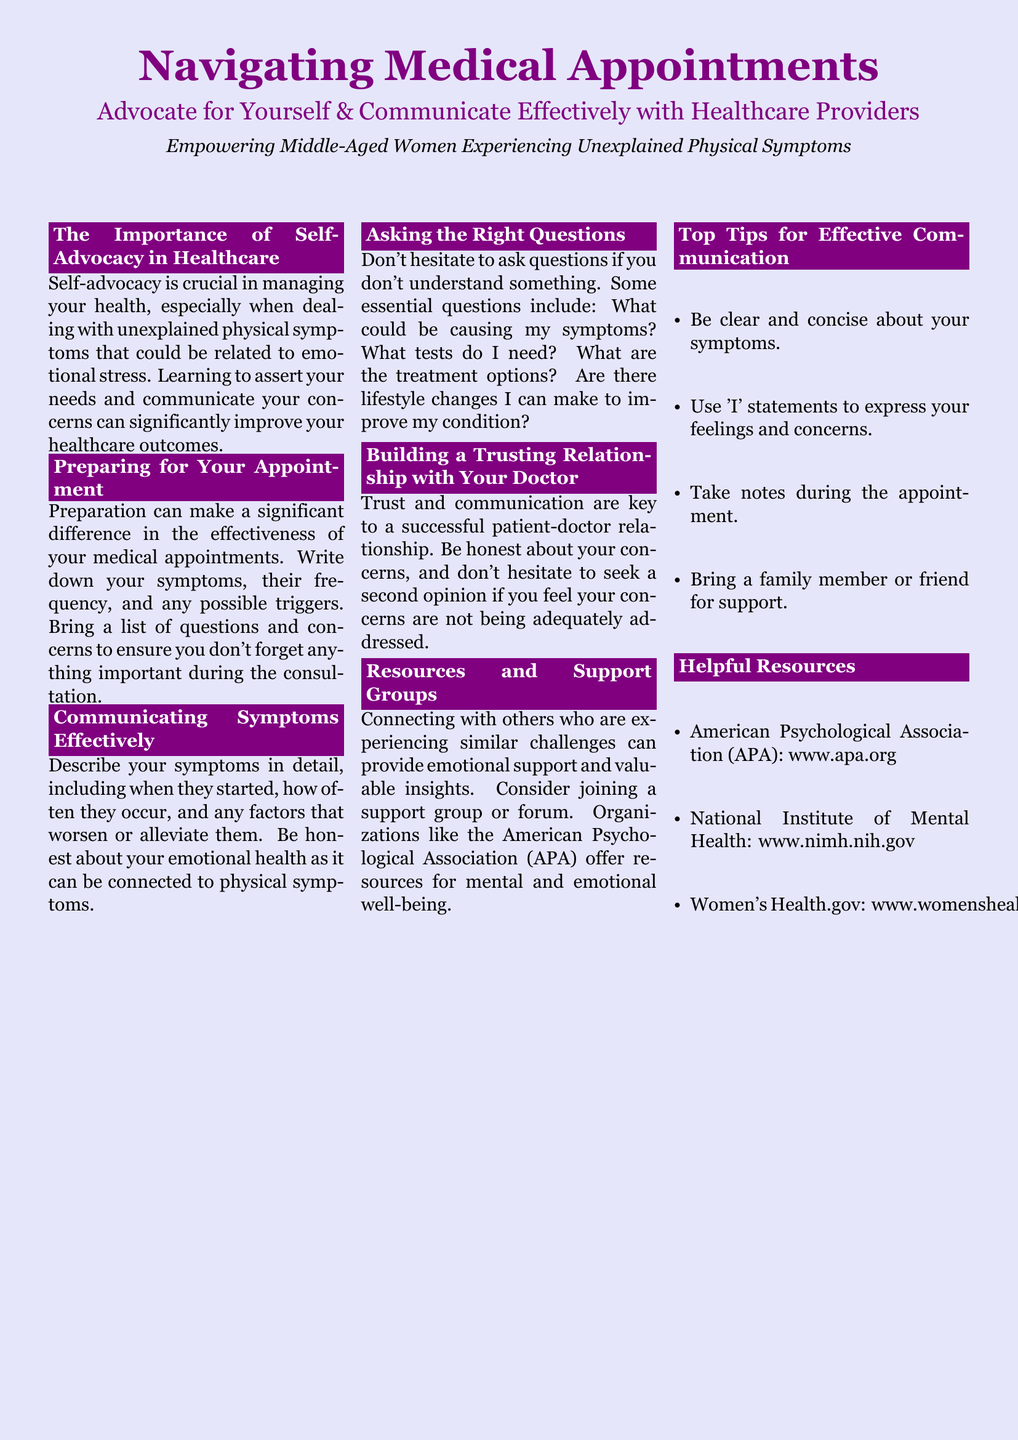What is the main focus of the document? The main focus is on empowering middle-aged women to effectively advocate for themselves in healthcare.
Answer: empowering middle-aged women What is one primary aspect of self-advocacy in healthcare? Self-advocacy is crucial in managing health, especially for those with unexplained symptoms.
Answer: managing health What should you bring to your medical appointment for better preparation? It is suggested to bring a list of symptoms, questions, and concerns to the appointment.
Answer: list of symptoms What type of statements are recommended for expressing feelings? The document advises using 'I' statements to express feelings and concerns.
Answer: 'I' statements Which organization offers resources for mental and emotional well-being? The document mentions the American Psychological Association as a resource for support.
Answer: American Psychological Association What is one tip for effective communication during appointments? One tip is to take notes during the appointment for better clarity.
Answer: take notes What can enhance the patient-doctor relationship? Building trust and communication can enhance the patient-doctor relationship.
Answer: trust and communication What are some examples of helpful resources listed in the document? The document lists the American Psychological Association and National Institute of Mental Health as resources.
Answer: American Psychological Association, National Institute of Mental Health What is the recommended action if you feel your concerns are not addressed? The document suggests seeking a second opinion if concerns aren't adequately addressed.
Answer: seek a second opinion 